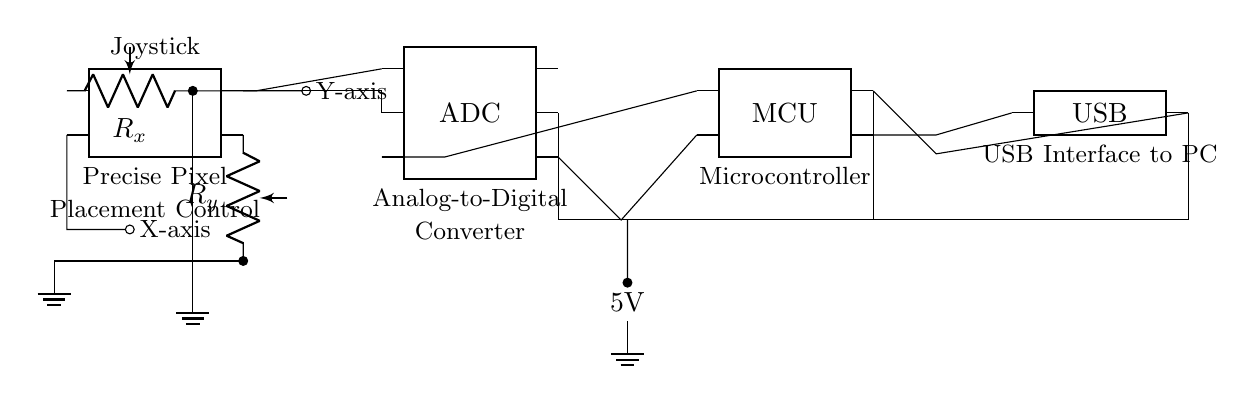What type of circuit is this? This circuit is an interface for a joystick used to control pixel placement in level design tools. It connects various components like the joystick, ADC, and microcontroller for input processing.
Answer: Interface circuit What does the joystick control in this circuit? The joystick controls two parameters, X-axis and Y-axis, which correspond to the placement of pixels on a screen, enabling precise movement in design tools.
Answer: X-axis and Y-axis What component converts analog signals to digital signals? The Analog-to-Digital Converter (ADC) converts the analog signals from the joystick's potentiometers into digital signals that the microcontroller can process.
Answer: ADC How is the circuit powered? The circuit is powered by a 5V battery, which provides the necessary voltage for all the components, connecting through a common power line.
Answer: 5V battery What is the purpose of the microcontroller in this circuit? The microcontroller processes the digital signals from the ADC, interprets the joystick movements, and sends the corresponding data to the USB interface for communication with a PC.
Answer: Data processing How many pins does the joystick have? The joystick has four pins that facilitate the connection to the potentiometers and signal outputs for X-axis and Y-axis movements.
Answer: Four pins Which component provides the USB interface in this circuit? The USB interface is provided by a dedicated USB chip that communicates the processed data from the microcontroller to the PC, enabling external interaction with the circuit.
Answer: USB 